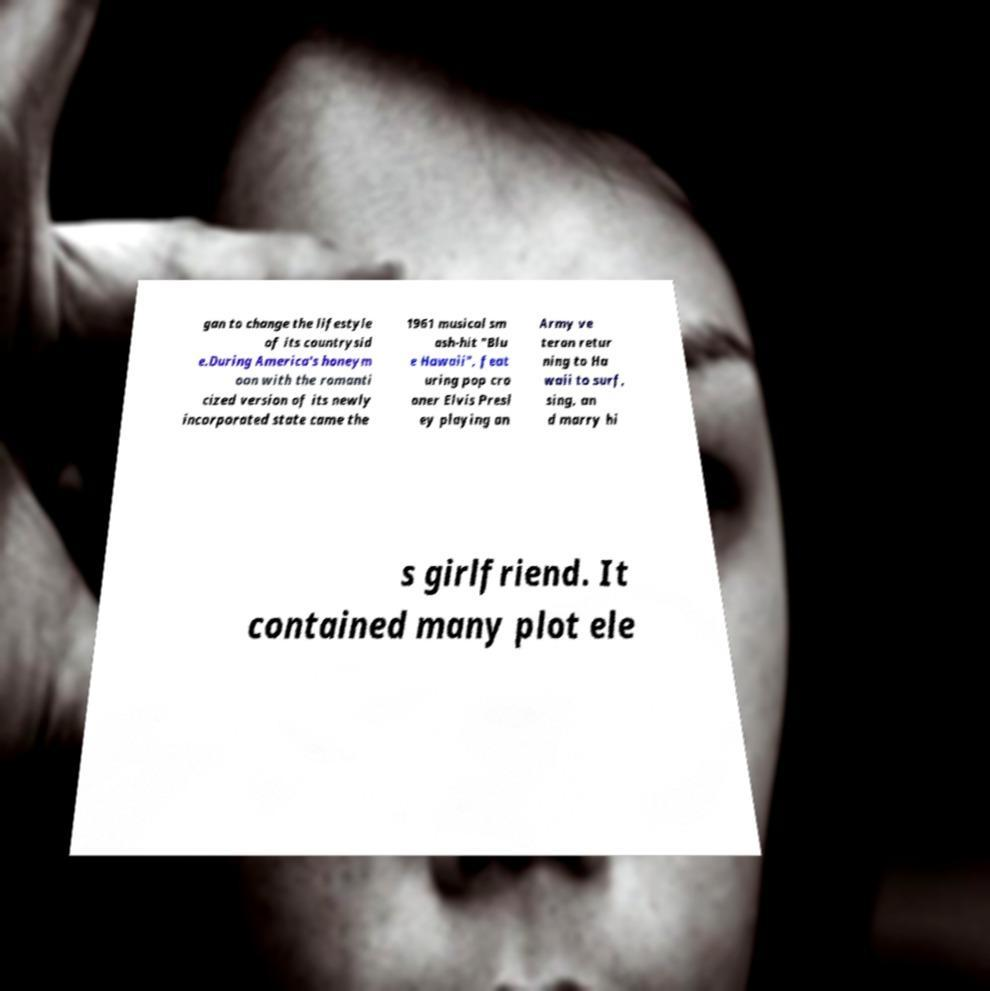Please identify and transcribe the text found in this image. gan to change the lifestyle of its countrysid e.During America's honeym oon with the romanti cized version of its newly incorporated state came the 1961 musical sm ash-hit "Blu e Hawaii", feat uring pop cro oner Elvis Presl ey playing an Army ve teran retur ning to Ha waii to surf, sing, an d marry hi s girlfriend. It contained many plot ele 